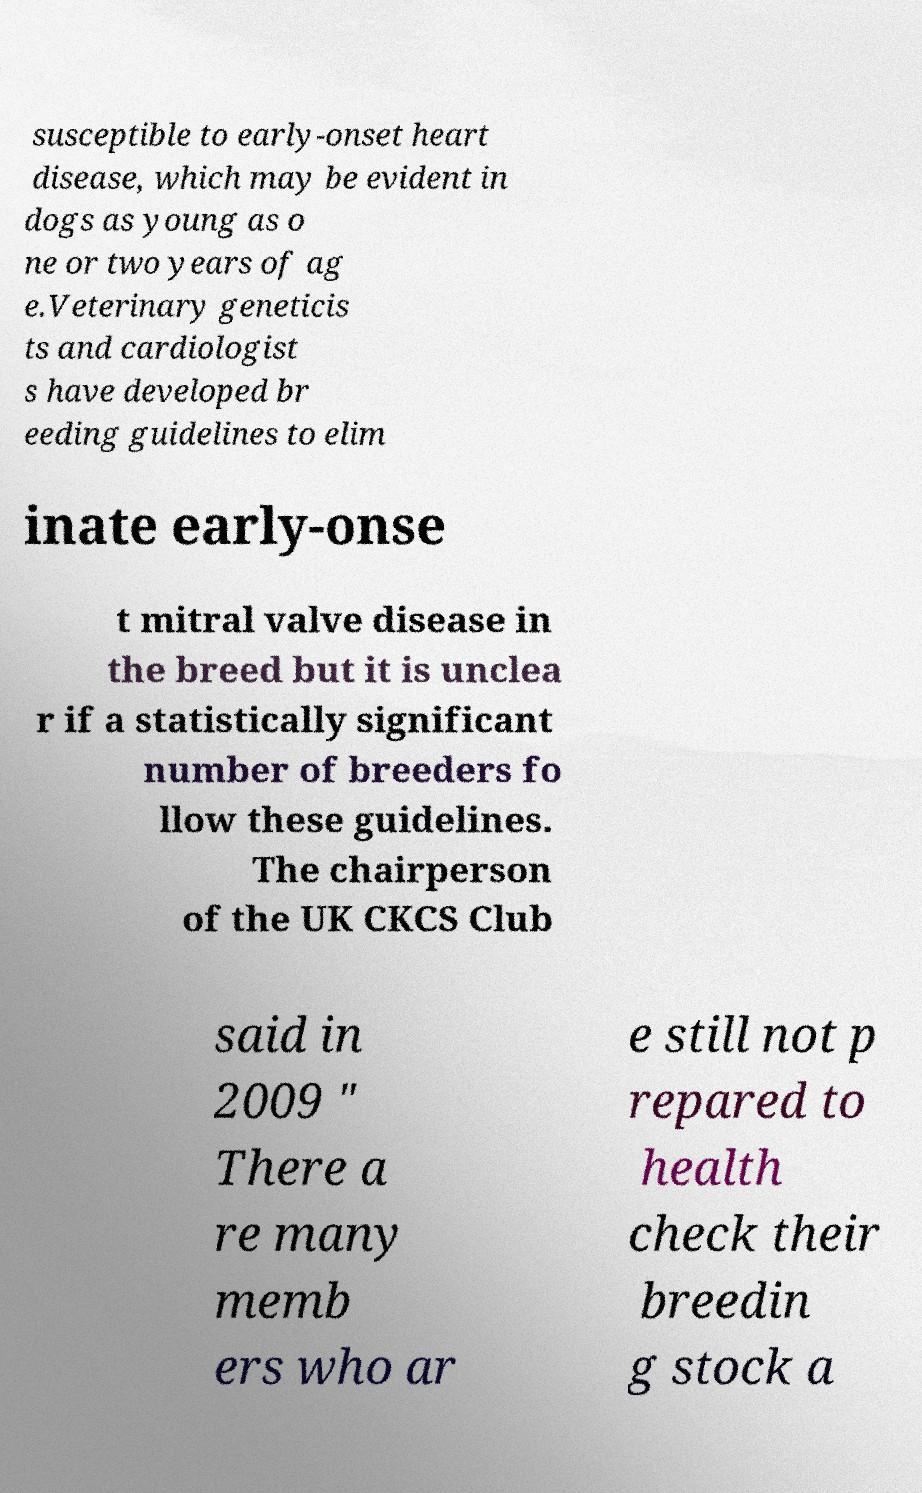For documentation purposes, I need the text within this image transcribed. Could you provide that? susceptible to early-onset heart disease, which may be evident in dogs as young as o ne or two years of ag e.Veterinary geneticis ts and cardiologist s have developed br eeding guidelines to elim inate early-onse t mitral valve disease in the breed but it is unclea r if a statistically significant number of breeders fo llow these guidelines. The chairperson of the UK CKCS Club said in 2009 " There a re many memb ers who ar e still not p repared to health check their breedin g stock a 